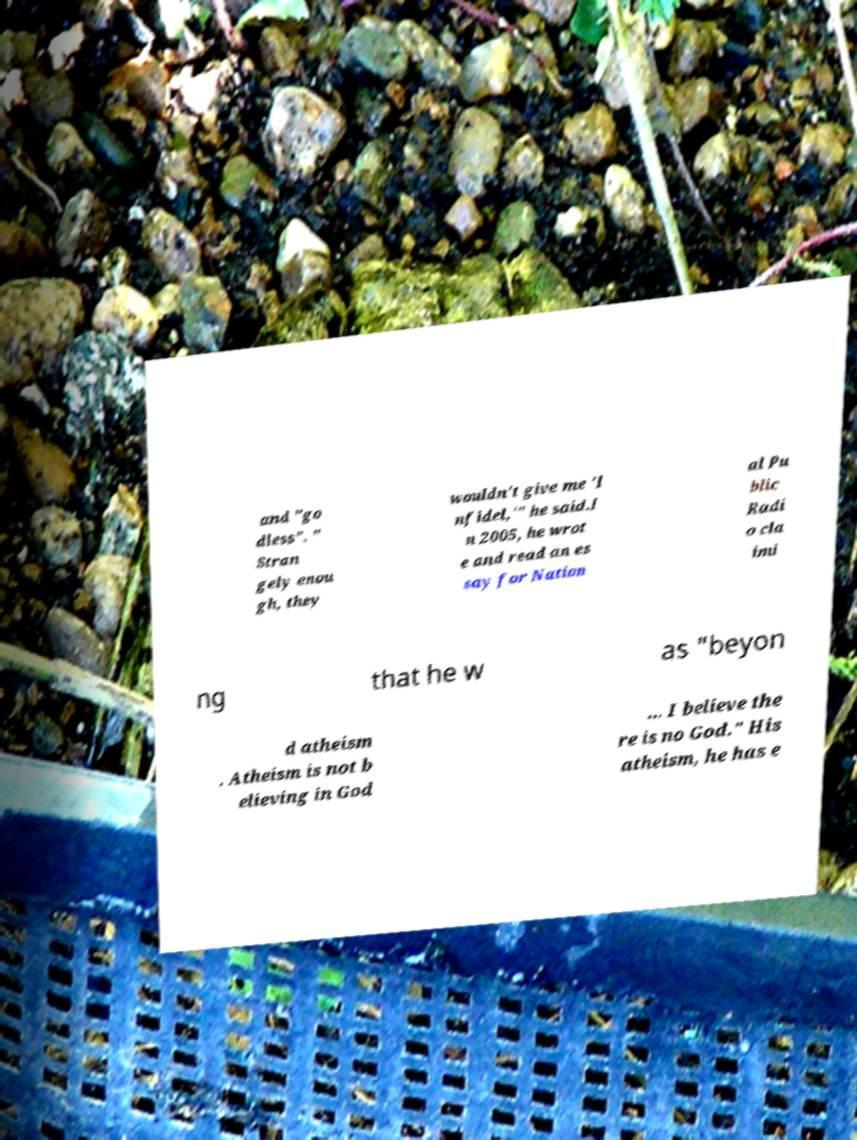Could you assist in decoding the text presented in this image and type it out clearly? and "go dless". " Stran gely enou gh, they wouldn't give me 'I nfidel,'" he said.I n 2005, he wrot e and read an es say for Nation al Pu blic Radi o cla imi ng that he w as "beyon d atheism . Atheism is not b elieving in God ... I believe the re is no God." His atheism, he has e 